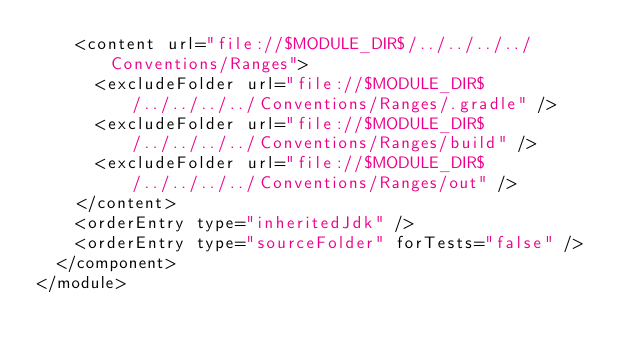<code> <loc_0><loc_0><loc_500><loc_500><_XML_>    <content url="file://$MODULE_DIR$/../../../../Conventions/Ranges">
      <excludeFolder url="file://$MODULE_DIR$/../../../../Conventions/Ranges/.gradle" />
      <excludeFolder url="file://$MODULE_DIR$/../../../../Conventions/Ranges/build" />
      <excludeFolder url="file://$MODULE_DIR$/../../../../Conventions/Ranges/out" />
    </content>
    <orderEntry type="inheritedJdk" />
    <orderEntry type="sourceFolder" forTests="false" />
  </component>
</module></code> 